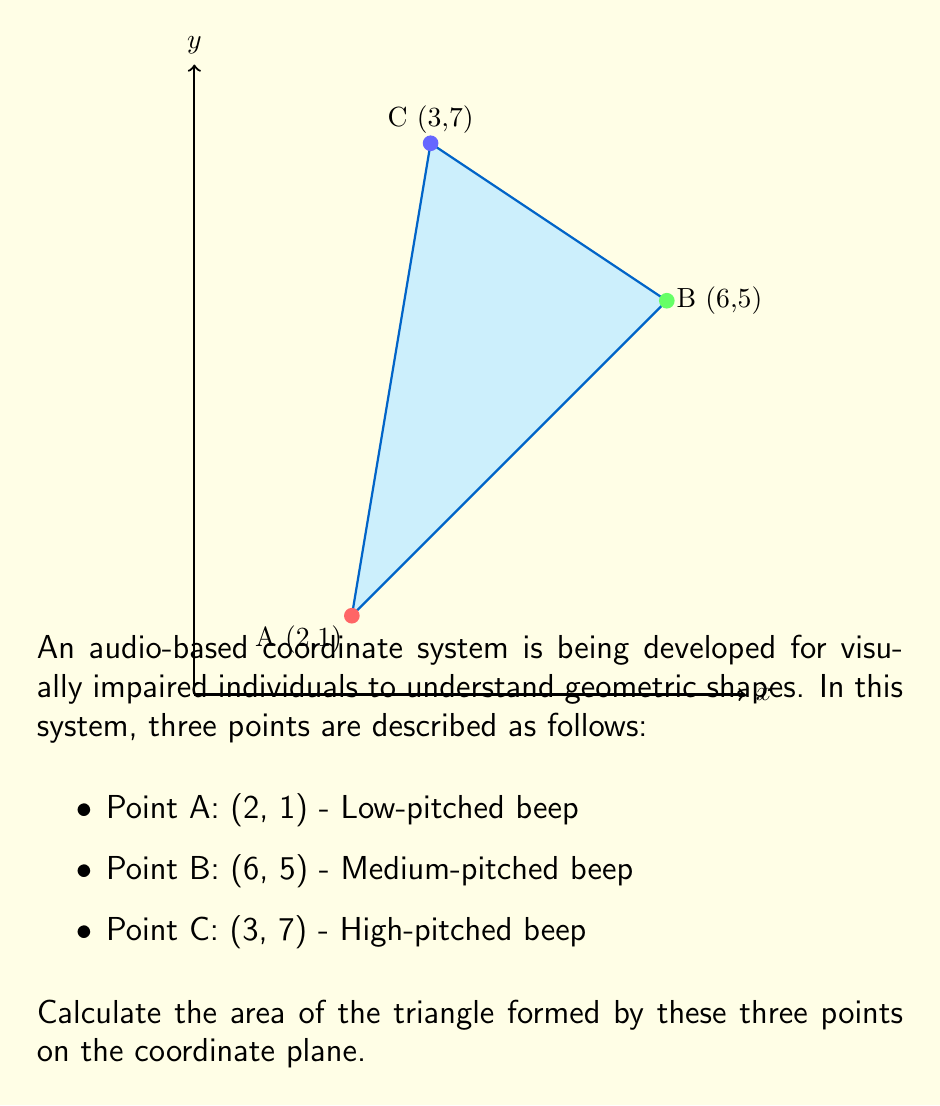Solve this math problem. To calculate the area of a triangle given three points on a coordinate plane, we can use the formula:

$$ \text{Area} = \frac{1}{2}|\det(\mathbf{v}_1, \mathbf{v}_2)| $$

Where $\mathbf{v}_1$ and $\mathbf{v}_2$ are vectors from one point to the other two points.

Step 1: Choose a point as the origin and create two vectors.
Let's choose point A (2,1) as our origin.
$\mathbf{v}_1 = B - A = (6-2, 5-1) = (4, 4)$
$\mathbf{v}_2 = C - A = (3-2, 7-1) = (1, 6)$

Step 2: Set up the determinant.
$$ \det(\mathbf{v}_1, \mathbf{v}_2) = \begin{vmatrix} 
4 & 1 \\
4 & 6
\end{vmatrix} $$

Step 3: Calculate the determinant.
$$ \det(\mathbf{v}_1, \mathbf{v}_2) = (4 \times 6) - (1 \times 4) = 24 - 4 = 20 $$

Step 4: Apply the area formula.
$$ \text{Area} = \frac{1}{2}|20| = 10 $$

Therefore, the area of the triangle is 10 square units.
Answer: 10 square units 